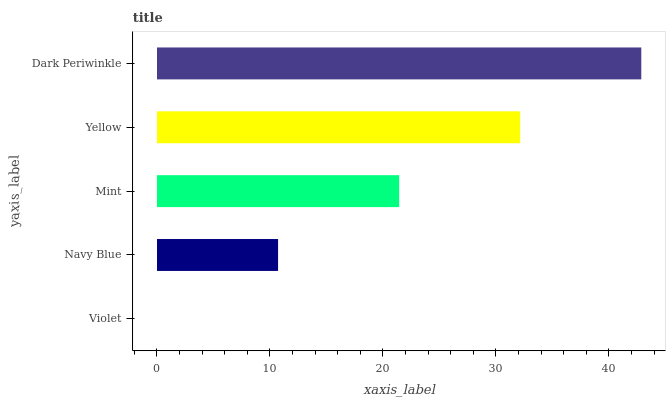Is Violet the minimum?
Answer yes or no. Yes. Is Dark Periwinkle the maximum?
Answer yes or no. Yes. Is Navy Blue the minimum?
Answer yes or no. No. Is Navy Blue the maximum?
Answer yes or no. No. Is Navy Blue greater than Violet?
Answer yes or no. Yes. Is Violet less than Navy Blue?
Answer yes or no. Yes. Is Violet greater than Navy Blue?
Answer yes or no. No. Is Navy Blue less than Violet?
Answer yes or no. No. Is Mint the high median?
Answer yes or no. Yes. Is Mint the low median?
Answer yes or no. Yes. Is Yellow the high median?
Answer yes or no. No. Is Navy Blue the low median?
Answer yes or no. No. 